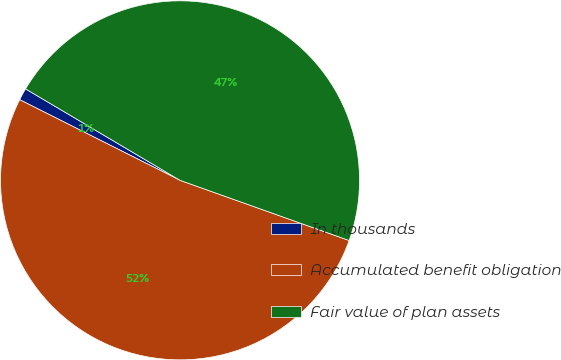Convert chart. <chart><loc_0><loc_0><loc_500><loc_500><pie_chart><fcel>In thousands<fcel>Accumulated benefit obligation<fcel>Fair value of plan assets<nl><fcel>1.09%<fcel>51.97%<fcel>46.93%<nl></chart> 